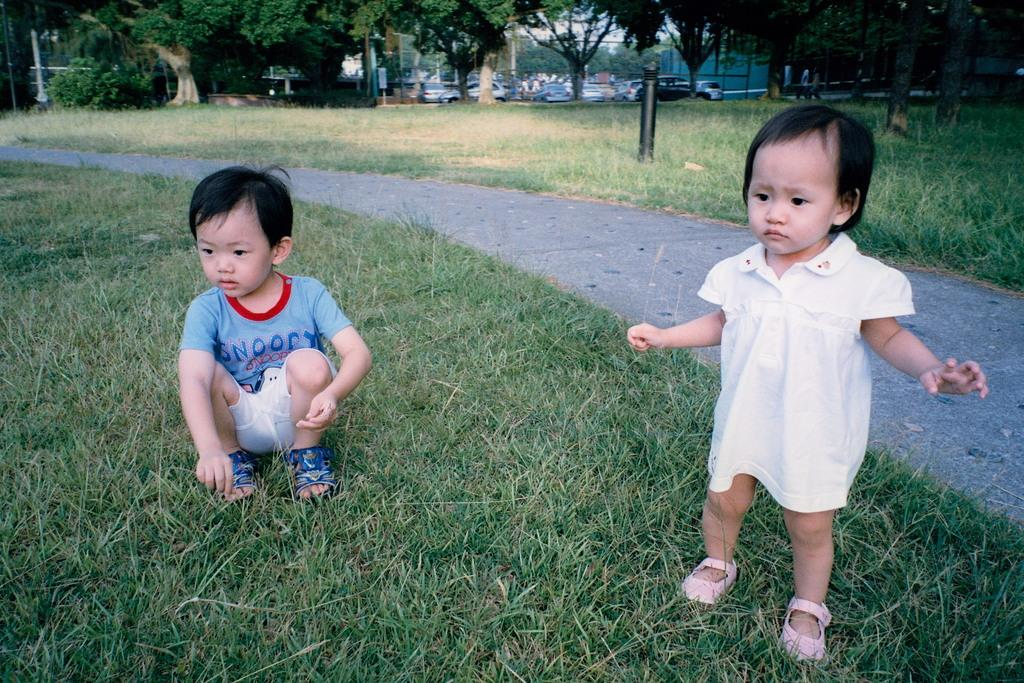<image>
Create a compact narrative representing the image presented. Little boy wearing a shirt which says Snoopy picking the grass. 